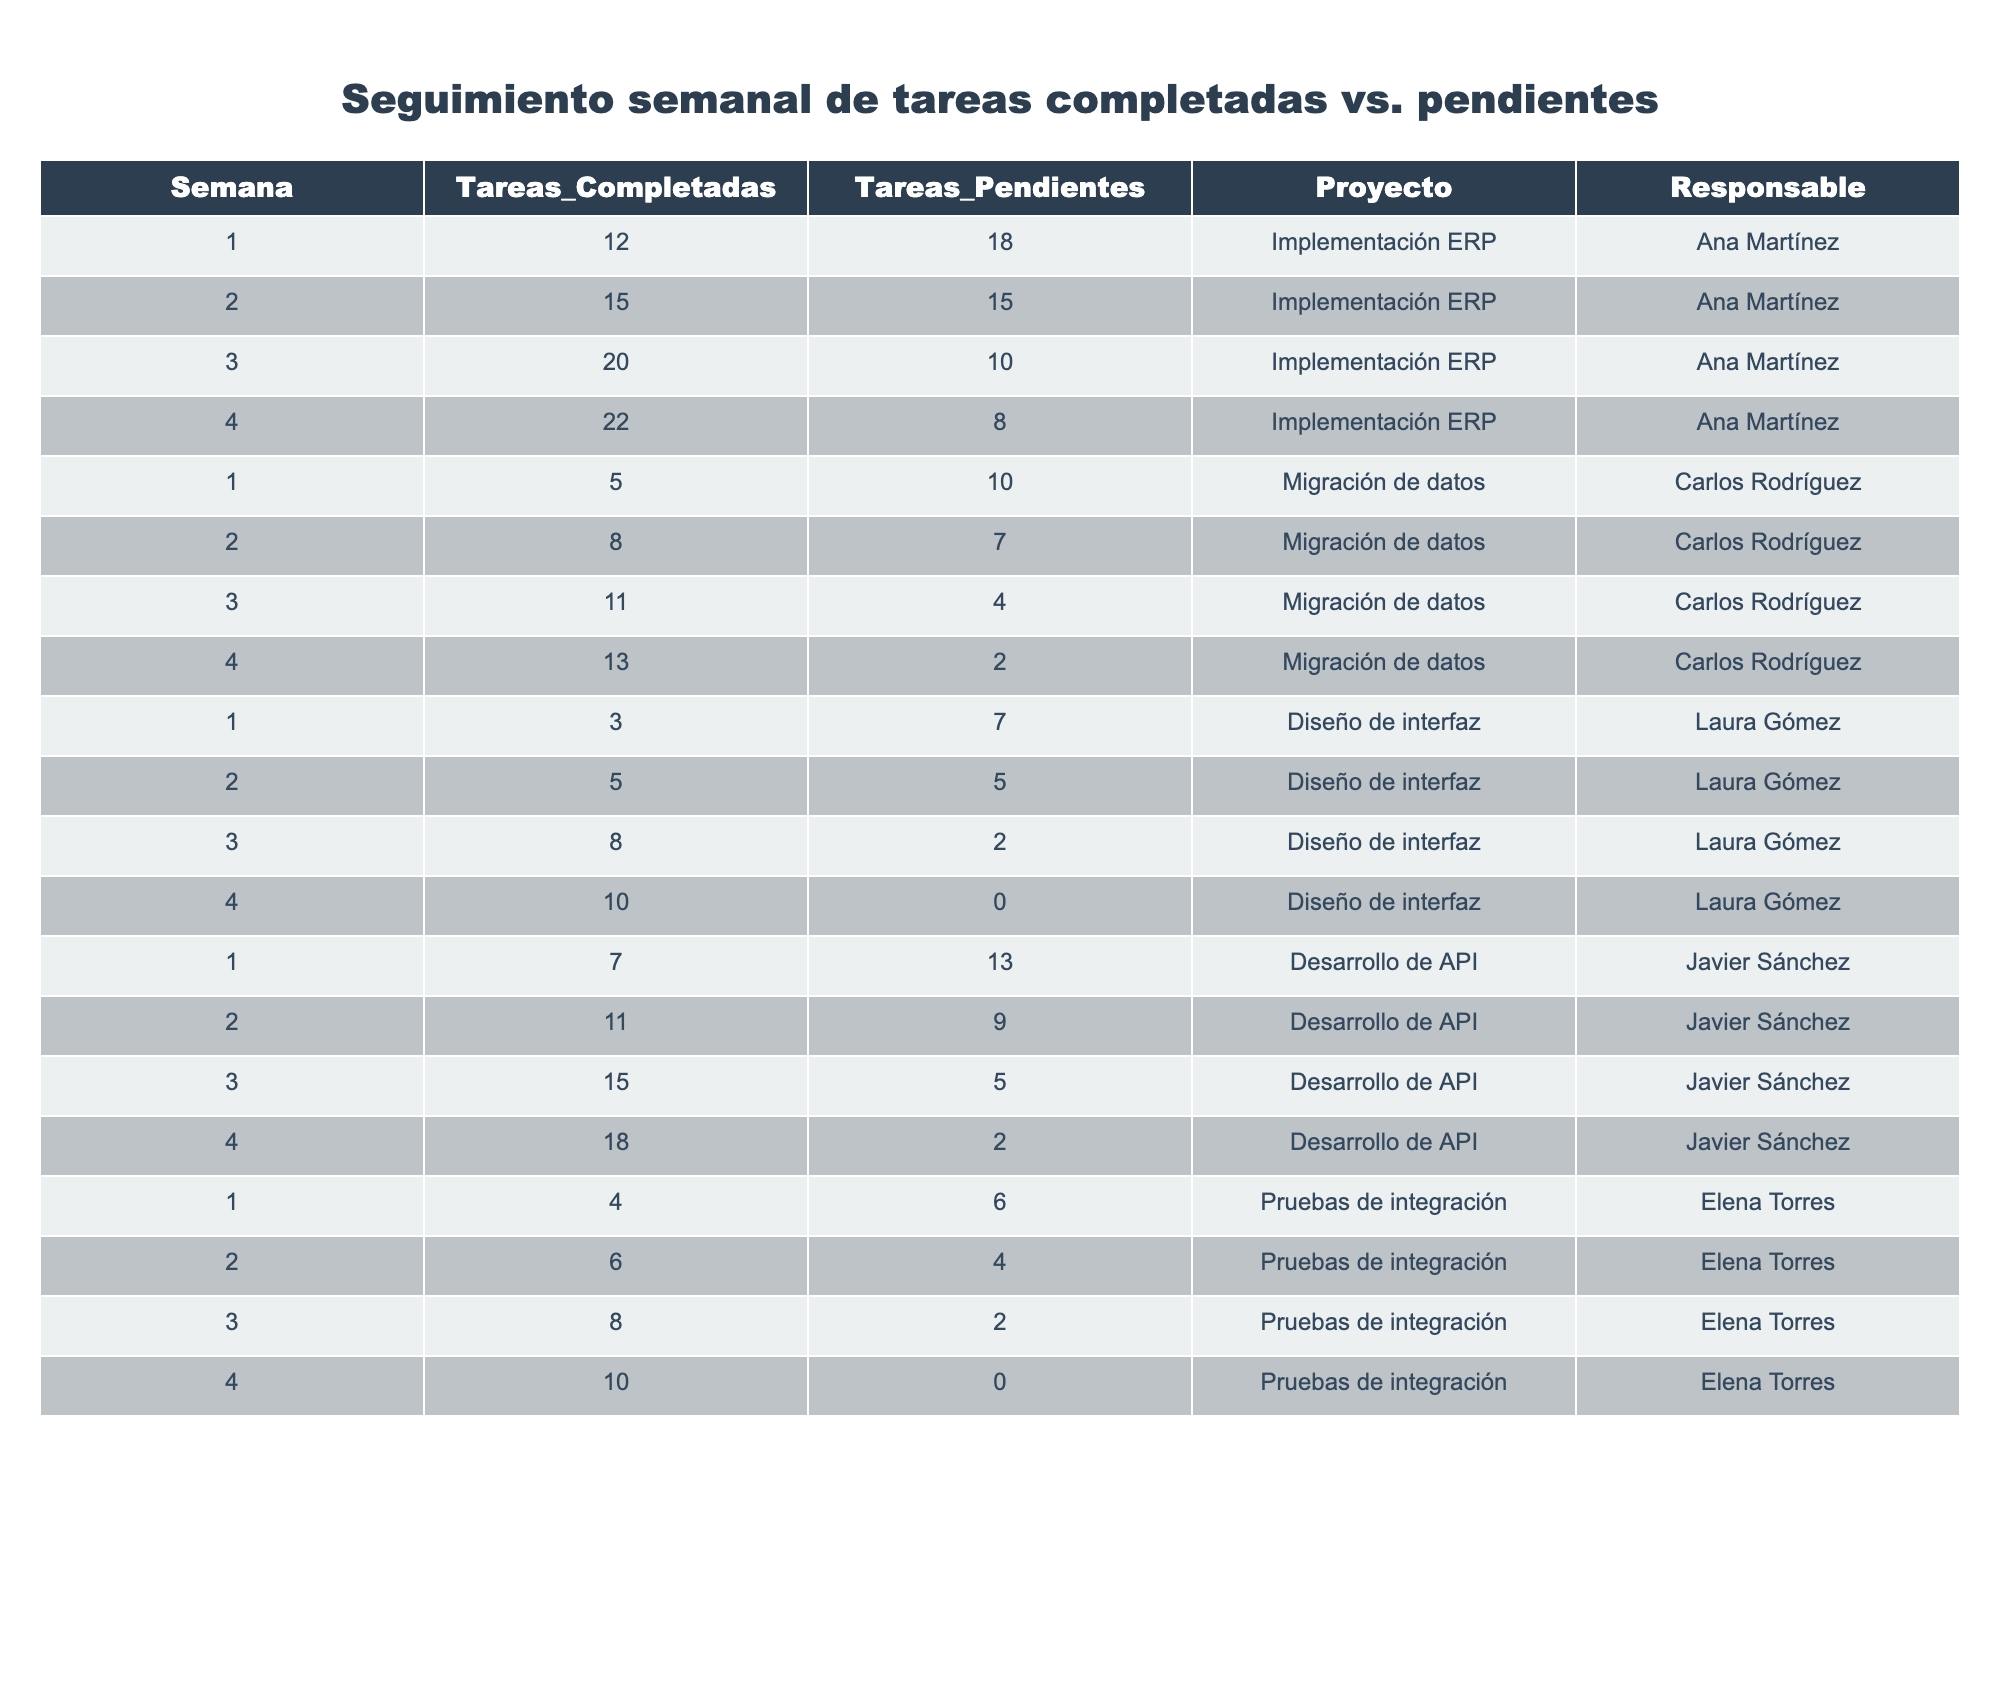¿Cuántas tareas completadas hubo en la semana 3 del proyecto 'Implementación ERP'? En la semana 3, las tareas completadas para el proyecto 'Implementación ERP' son 20, según la tabla.
Answer: 20 ¿Cuántas tareas pendientes tiene el proyecto 'Desarrollo de API' en total? En la tabla, las tareas pendientes para 'Desarrollo de API' son 13 en la semana 1, 9 en la semana 2, 5 en la semana 3 y 2 en la semana 4. Sumando estos valores, tenemos 13 + 9 + 5 + 2 = 29 tareas pendientes.
Answer: 29 ¿Cuál es el responsable del proyecto con más tareas completadas en la semana 4? En la semana 4, los valores de tareas completadas son 22 para 'Implementación ERP', 13 para 'Migración de datos', 10 para 'Diseño de interfaz', 18 para 'Desarrollo de API', y 10 para 'Pruebas de integración'. El mayor valor es 22, que corresponde a Ana Martínez en 'Implementación ERP'.
Answer: Ana Martínez ¿Cuántas tareas completadas hay en total para el proyecto 'Pruebas de integración'? Para el proyecto 'Pruebas de integración', las tareas completadas son 4 en la semana 1, 6 en la semana 2, 8 en la semana 3 y 10 en la semana 4. Sumando estos valores, obtenemos 4 + 6 + 8 + 10 = 28.
Answer: 28 ¿El proyecto 'Migración de datos' tuvo más tareas completadas que tareas pendientes en alguna semana? En la semana 1, completó 5 tareas y tenía 10 pendientes. En la semana 2, completó 8 y tenía 7 pendientes. En la semana 3, completó 11 y tenía 4 pendientes. En la semana 4, completó 13 y tenía 2 pendientes. En ninguna semana completó más tareas de las que tenía pendientes.
Answer: No ¿Cuál es la diferencia entre las tareas completadas y las tareas pendientes en la semana 2 para el proyecto 'Desarrollo de API'? En la semana 2, 'Desarrollo de API' tiene 11 tareas completadas y 9 tareas pendientes. La diferencia se calcula restando las tareas completadas a las pendientes: 9 - 11 = -2, lo que indica que se completaron más tareas de las que estaban pendientes.
Answer: -2 ¿Cuál proyecto tiene el menor número de tareas pendientes en la semana 4? En la semana 4, los proyectos tienen las siguientes tareas pendientes: 'Implementación ERP' (8), 'Migración de datos' (2), 'Diseño de interfaz' (0), 'Desarrollo de API' (2) y 'Pruebas de integración' (0). Los proyectos 'Diseño de interfaz' y 'Pruebas de integración' tienen el menor número de tareas pendientes, que es 0.
Answer: Diseño de interfaz y Pruebas de integración ¿Cuántas tareas se completaron en total durante las 4 semanas del proyecto 'Diseño de interfaz'? Las tareas completadas en las semanas 1, 2, 3 y 4 para 'Diseño de interfaz' son 3, 5, 8 y 10, respectivamente. Sumando estas, tenemos 3 + 5 + 8 + 10 = 26 tareas completadas en total.
Answer: 26 ¿Cuál fue el promedio de tareas pendientes a lo largo de las 4 semanas para el proyecto 'Implementación ERP'? El número de tareas pendientes en 'Implementación ERP' en las semanas 1, 2, 3 y 4 es 18, 15, 10 y 8. Calculamos el promedio sumando estos (18 + 15 + 10 + 8 = 51) y dividiendo entre el número de semanas (51 / 4 = 12.75).
Answer: 12.75 